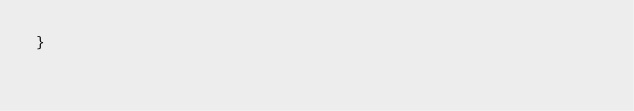Convert code to text. <code><loc_0><loc_0><loc_500><loc_500><_TypeScript_>}
</code> 